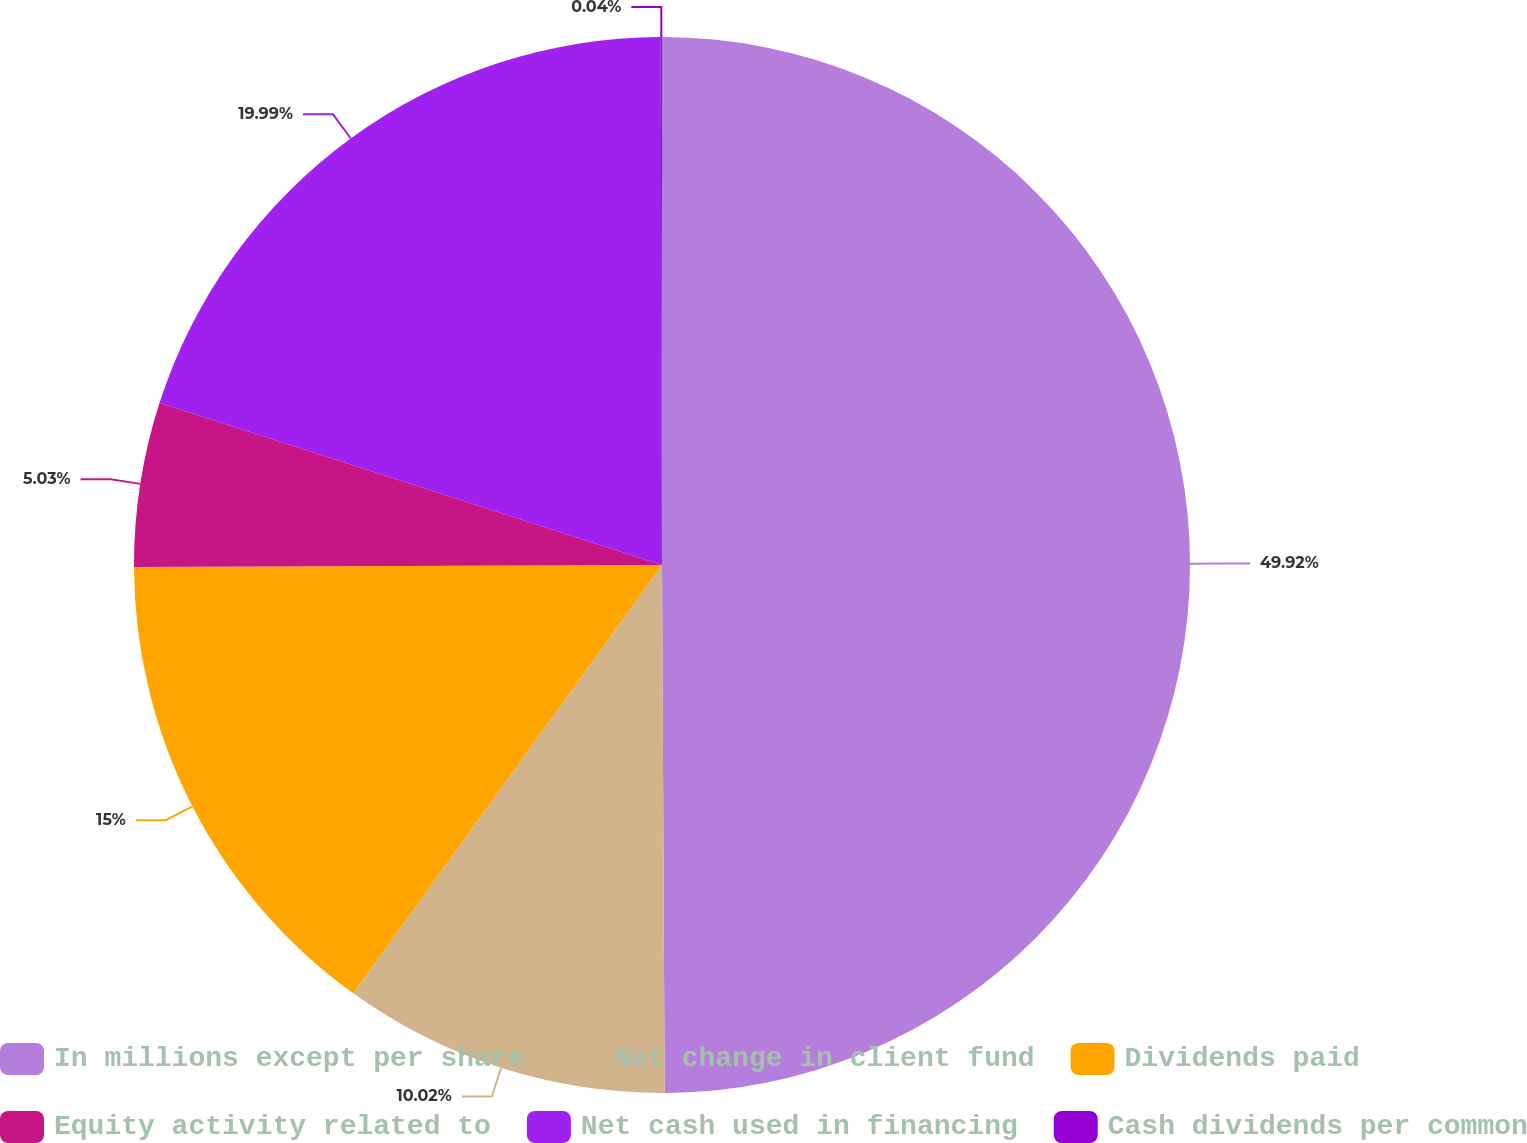Convert chart. <chart><loc_0><loc_0><loc_500><loc_500><pie_chart><fcel>In millions except per share<fcel>Net change in client fund<fcel>Dividends paid<fcel>Equity activity related to<fcel>Net cash used in financing<fcel>Cash dividends per common<nl><fcel>49.92%<fcel>10.02%<fcel>15.0%<fcel>5.03%<fcel>19.99%<fcel>0.04%<nl></chart> 